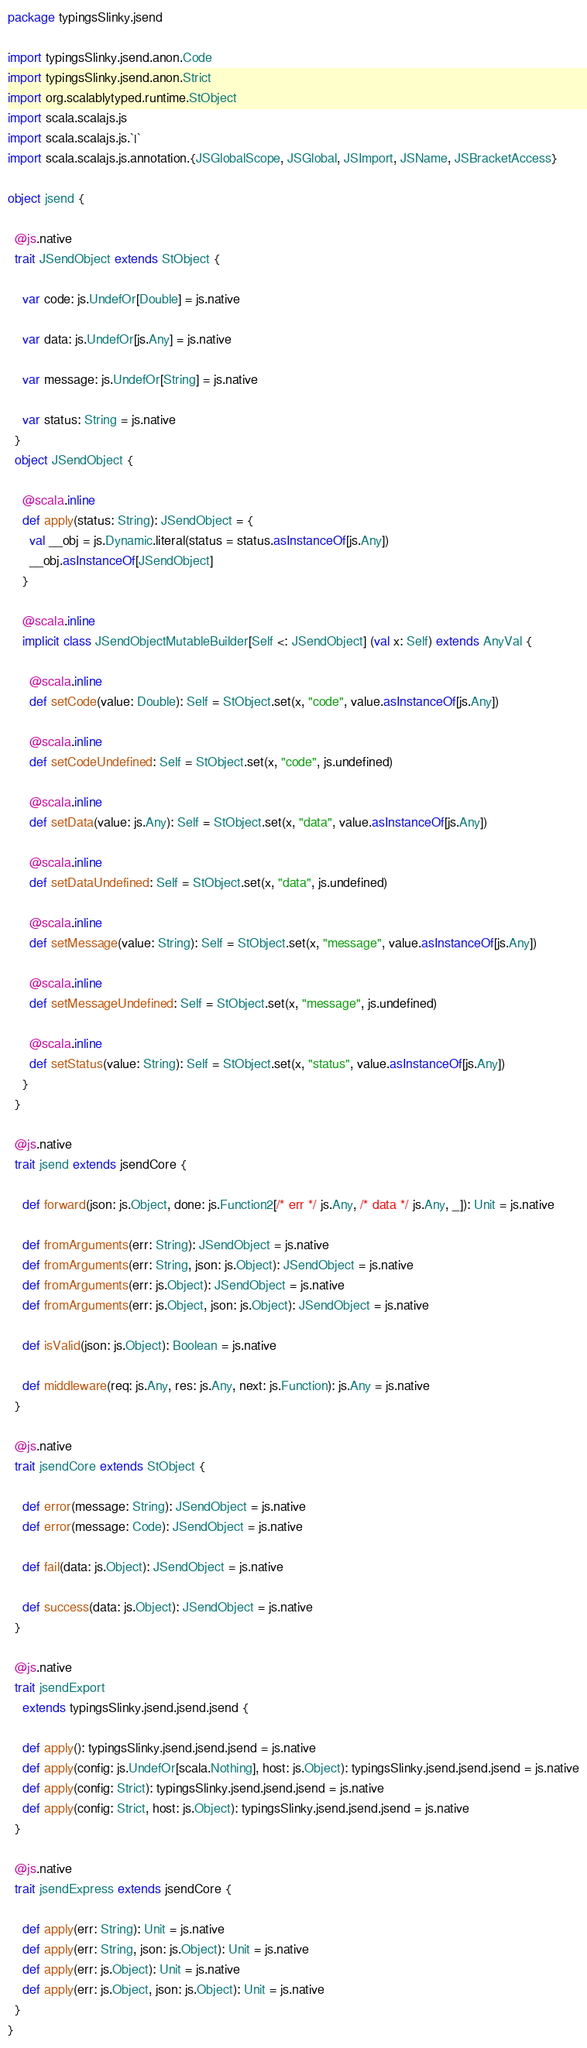Convert code to text. <code><loc_0><loc_0><loc_500><loc_500><_Scala_>package typingsSlinky.jsend

import typingsSlinky.jsend.anon.Code
import typingsSlinky.jsend.anon.Strict
import org.scalablytyped.runtime.StObject
import scala.scalajs.js
import scala.scalajs.js.`|`
import scala.scalajs.js.annotation.{JSGlobalScope, JSGlobal, JSImport, JSName, JSBracketAccess}

object jsend {
  
  @js.native
  trait JSendObject extends StObject {
    
    var code: js.UndefOr[Double] = js.native
    
    var data: js.UndefOr[js.Any] = js.native
    
    var message: js.UndefOr[String] = js.native
    
    var status: String = js.native
  }
  object JSendObject {
    
    @scala.inline
    def apply(status: String): JSendObject = {
      val __obj = js.Dynamic.literal(status = status.asInstanceOf[js.Any])
      __obj.asInstanceOf[JSendObject]
    }
    
    @scala.inline
    implicit class JSendObjectMutableBuilder[Self <: JSendObject] (val x: Self) extends AnyVal {
      
      @scala.inline
      def setCode(value: Double): Self = StObject.set(x, "code", value.asInstanceOf[js.Any])
      
      @scala.inline
      def setCodeUndefined: Self = StObject.set(x, "code", js.undefined)
      
      @scala.inline
      def setData(value: js.Any): Self = StObject.set(x, "data", value.asInstanceOf[js.Any])
      
      @scala.inline
      def setDataUndefined: Self = StObject.set(x, "data", js.undefined)
      
      @scala.inline
      def setMessage(value: String): Self = StObject.set(x, "message", value.asInstanceOf[js.Any])
      
      @scala.inline
      def setMessageUndefined: Self = StObject.set(x, "message", js.undefined)
      
      @scala.inline
      def setStatus(value: String): Self = StObject.set(x, "status", value.asInstanceOf[js.Any])
    }
  }
  
  @js.native
  trait jsend extends jsendCore {
    
    def forward(json: js.Object, done: js.Function2[/* err */ js.Any, /* data */ js.Any, _]): Unit = js.native
    
    def fromArguments(err: String): JSendObject = js.native
    def fromArguments(err: String, json: js.Object): JSendObject = js.native
    def fromArguments(err: js.Object): JSendObject = js.native
    def fromArguments(err: js.Object, json: js.Object): JSendObject = js.native
    
    def isValid(json: js.Object): Boolean = js.native
    
    def middleware(req: js.Any, res: js.Any, next: js.Function): js.Any = js.native
  }
  
  @js.native
  trait jsendCore extends StObject {
    
    def error(message: String): JSendObject = js.native
    def error(message: Code): JSendObject = js.native
    
    def fail(data: js.Object): JSendObject = js.native
    
    def success(data: js.Object): JSendObject = js.native
  }
  
  @js.native
  trait jsendExport
    extends typingsSlinky.jsend.jsend.jsend {
    
    def apply(): typingsSlinky.jsend.jsend.jsend = js.native
    def apply(config: js.UndefOr[scala.Nothing], host: js.Object): typingsSlinky.jsend.jsend.jsend = js.native
    def apply(config: Strict): typingsSlinky.jsend.jsend.jsend = js.native
    def apply(config: Strict, host: js.Object): typingsSlinky.jsend.jsend.jsend = js.native
  }
  
  @js.native
  trait jsendExpress extends jsendCore {
    
    def apply(err: String): Unit = js.native
    def apply(err: String, json: js.Object): Unit = js.native
    def apply(err: js.Object): Unit = js.native
    def apply(err: js.Object, json: js.Object): Unit = js.native
  }
}
</code> 